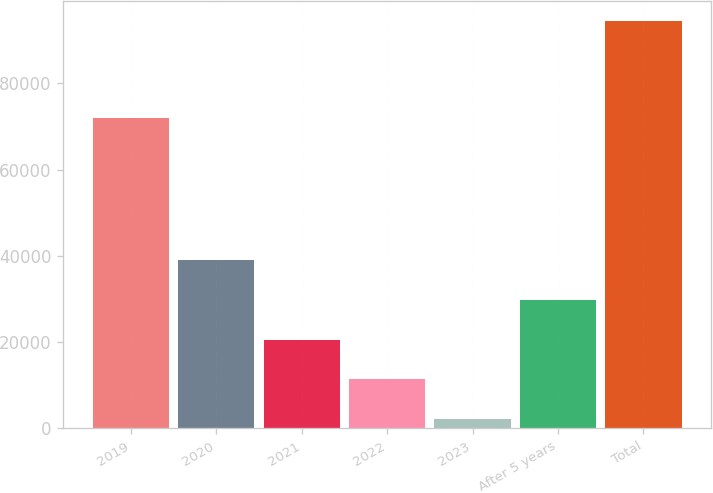Convert chart. <chart><loc_0><loc_0><loc_500><loc_500><bar_chart><fcel>2019<fcel>2020<fcel>2021<fcel>2022<fcel>2023<fcel>After 5 years<fcel>Total<nl><fcel>72016<fcel>39052.2<fcel>20571.6<fcel>11331.3<fcel>2091<fcel>29811.9<fcel>94494<nl></chart> 